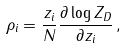Convert formula to latex. <formula><loc_0><loc_0><loc_500><loc_500>\rho _ { i } = \frac { z _ { i } } { N } \frac { \partial \log Z _ { D } } { \partial z _ { i } } \, ,</formula> 